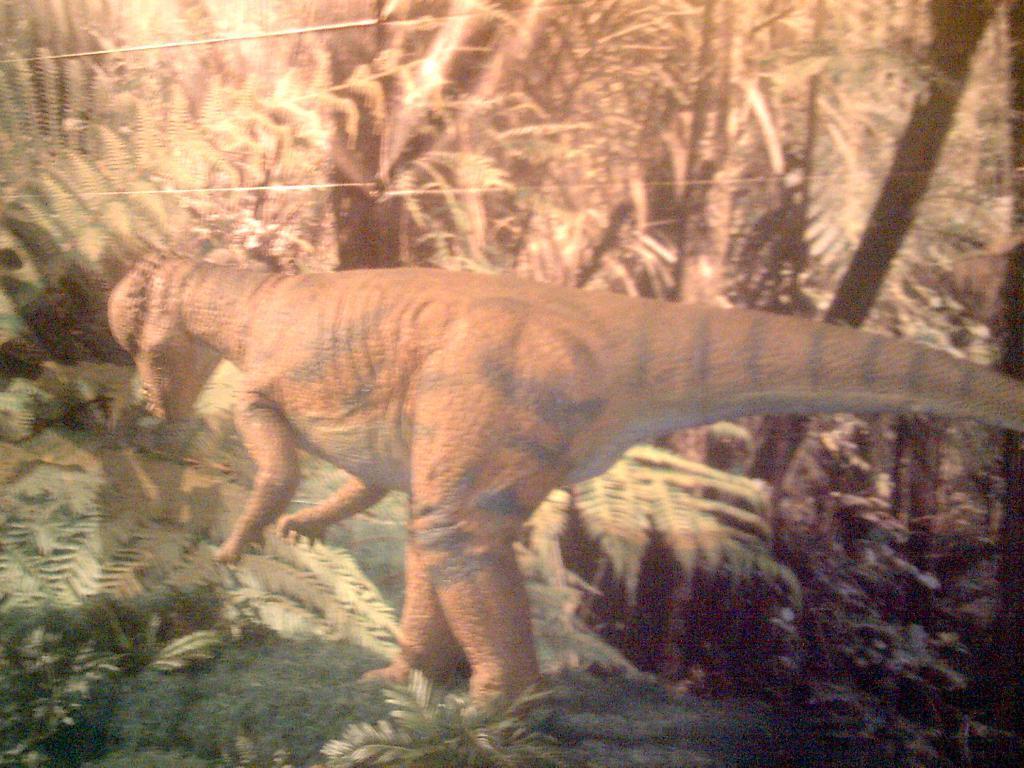How would you summarize this image in a sentence or two? In this image we can see a dinosaur, there are some plants, and trees. 